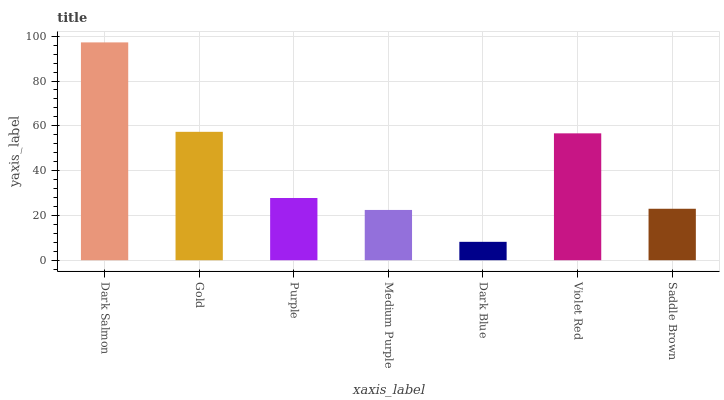Is Dark Blue the minimum?
Answer yes or no. Yes. Is Dark Salmon the maximum?
Answer yes or no. Yes. Is Gold the minimum?
Answer yes or no. No. Is Gold the maximum?
Answer yes or no. No. Is Dark Salmon greater than Gold?
Answer yes or no. Yes. Is Gold less than Dark Salmon?
Answer yes or no. Yes. Is Gold greater than Dark Salmon?
Answer yes or no. No. Is Dark Salmon less than Gold?
Answer yes or no. No. Is Purple the high median?
Answer yes or no. Yes. Is Purple the low median?
Answer yes or no. Yes. Is Saddle Brown the high median?
Answer yes or no. No. Is Dark Salmon the low median?
Answer yes or no. No. 